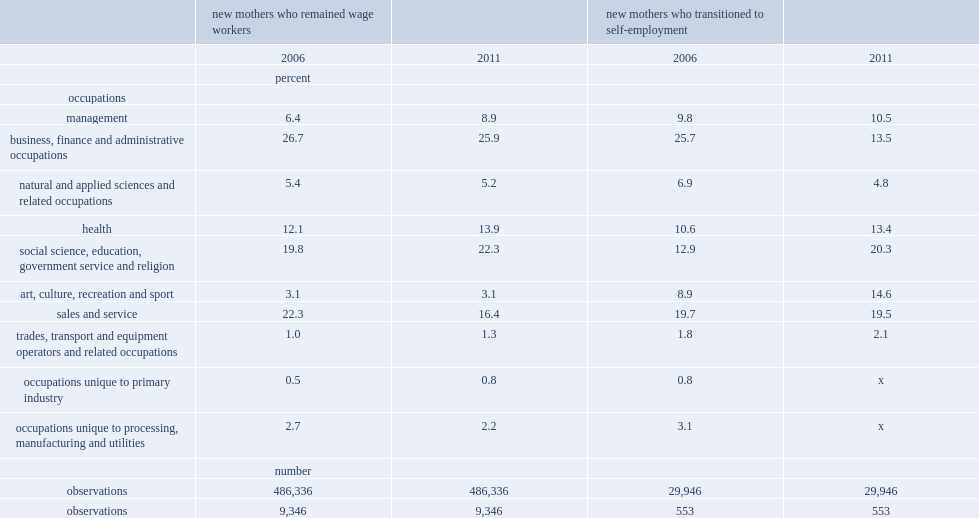Which share of occupations has a substantial decline in the occupational distribution of new mothers who remained in wage employment between 2006 and 2011? Sales and service. Which occupations show an increase in the distribution of new mothers who switched to self-empoloyment in 2011, compared with the 2006 distribution? Management health social science, education, government service and religion art, culture, recreation and sport trades, transport and equipment operators and related occupations. Which occupations have the least change in the distribution of new mothers who switched to self-employment, compared with the 2006 distribution? Sales and service. Which occupations have substantial reductions in the distribution of new mothers who switched to self-employment in 2011, compared with the 2006 distribution? Business, finance and administrative occupations natural and applied sciences and related occupations occupations unique to processing, manufacturing and utilities. 